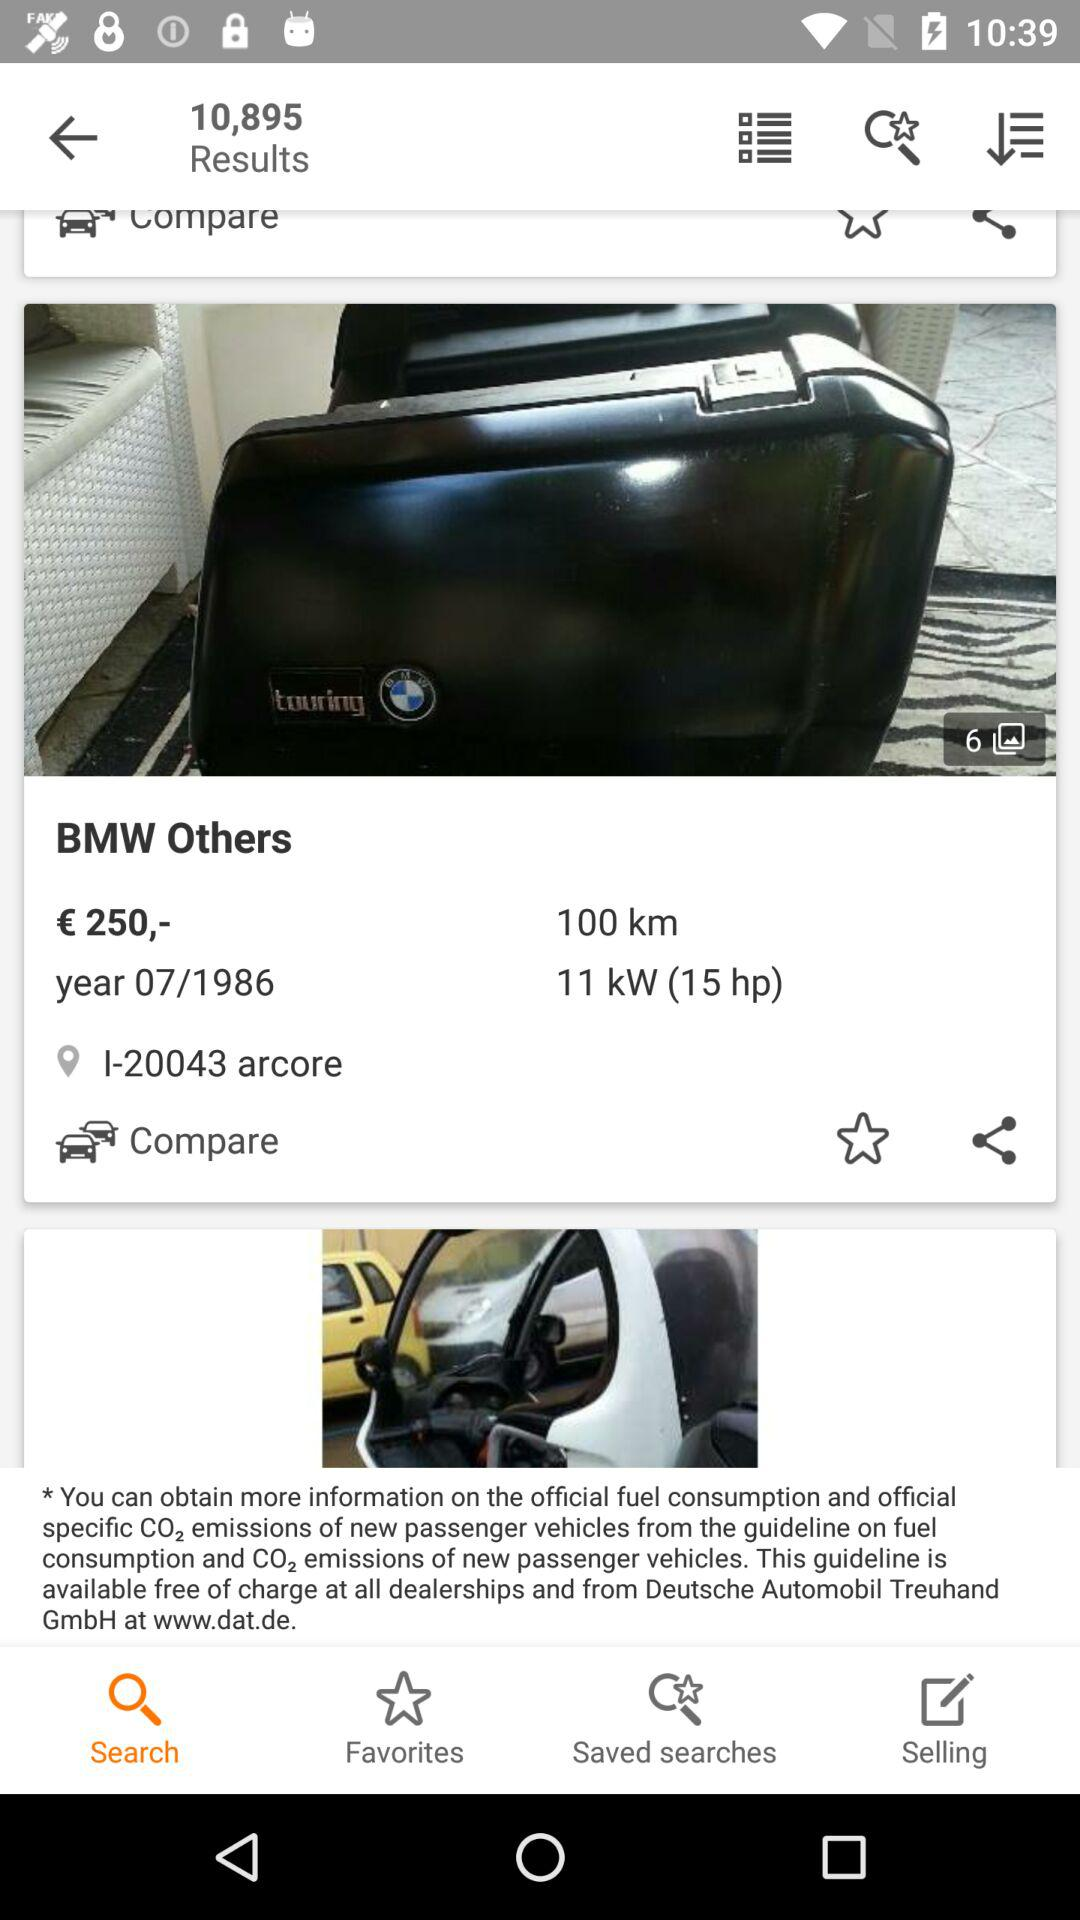In what year was "BMW Others" launched? "BMW Others" was launched in 1986. 